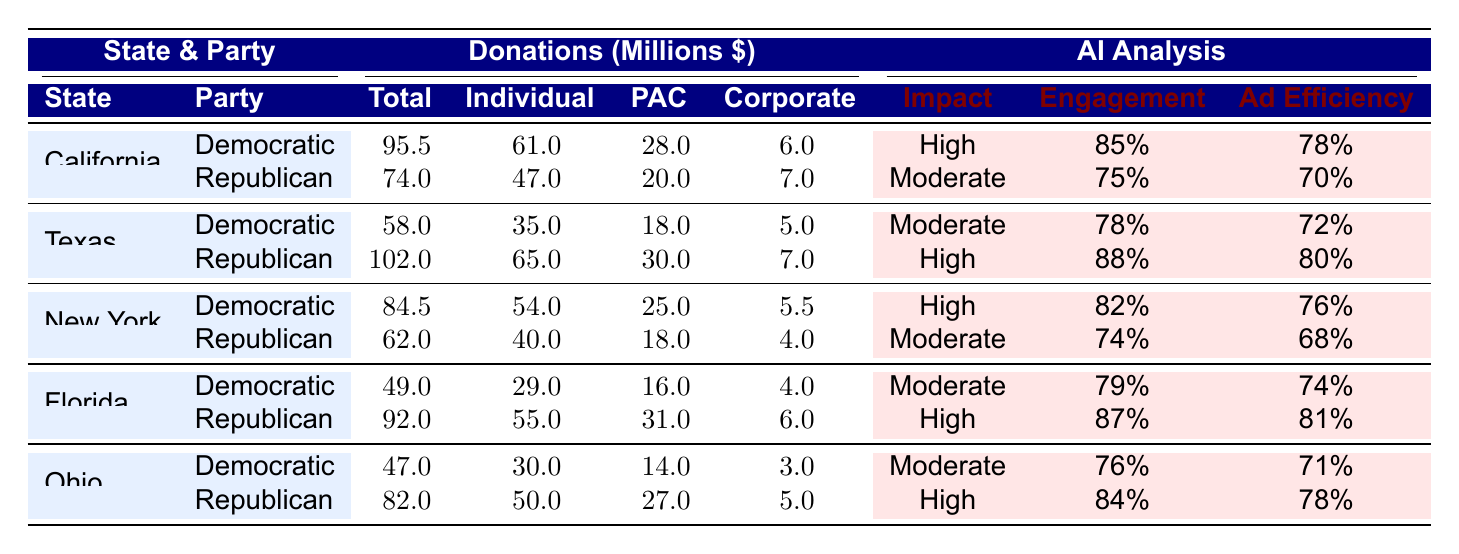What state received the highest total donations for the Democratic Party? Looking at the donations for the Democratic Party, California has the highest total donations at 95.5 million dollars.
Answer: California What is the total amount of corporate contributions for Republican donations in Texas? The table shows that corporate contributions for Republican donations in Texas amount to 7 million dollars.
Answer: 7 million dollars Which party has a higher expected impact on donations in New York? The Democratic Party shows an expected impact labeled as "High" while the Republican Party is labeled as "Moderate," indicating the Democratic Party has a higher expected impact.
Answer: Democratic Party What is the difference in total donations between the Republican and Democratic parties in Florida? The total donations for Republicans in Florida are 92 million and for Democrats are 49 million. The difference is 92 - 49 = 43 million dollars.
Answer: 43 million dollars Is the individual contribution for the Republican Party in Ohio greater than that in California? The individual contribution for Republicans in Ohio is 50 million dollars, which is greater than 47 million in California. Therefore, the statement is true.
Answer: Yes What is the average voter engagement for the Democratic Party across all states listed? The voter engagements for the Democratic Party are 85%, 78%, 82%, 79%, and 76%. Adding these gives 400%, and dividing by 5 provides an average of 80%.
Answer: 80% What total donation amount does Texas receive for all political parties combined? Adding the total donations for both parties in Texas: 58 million (Democratic) + 102 million (Republican) equals 160 million dollars.
Answer: 160 million dollars Are corporate contributions for the Democratic Party in California greater than those in New York? Corporate contributions for California (6 million) are compared to New York (5.5 million). Since 6 million is greater than 5.5 million, the statement is true.
Answer: Yes Which state has the highest total donations for the Republican Party? The total donations for the Republican Party are highest in Texas at 102 million dollars, more than any other state.
Answer: Texas 